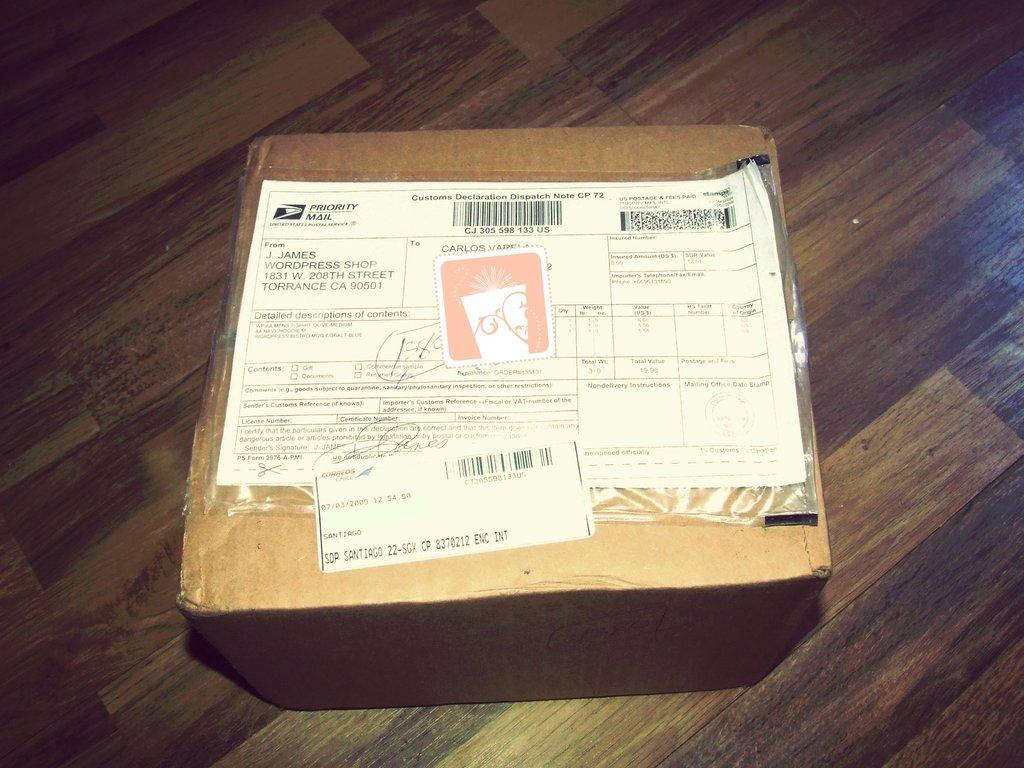<image>
Give a short and clear explanation of the subsequent image. A package that has a sticker for Priority Mail. 